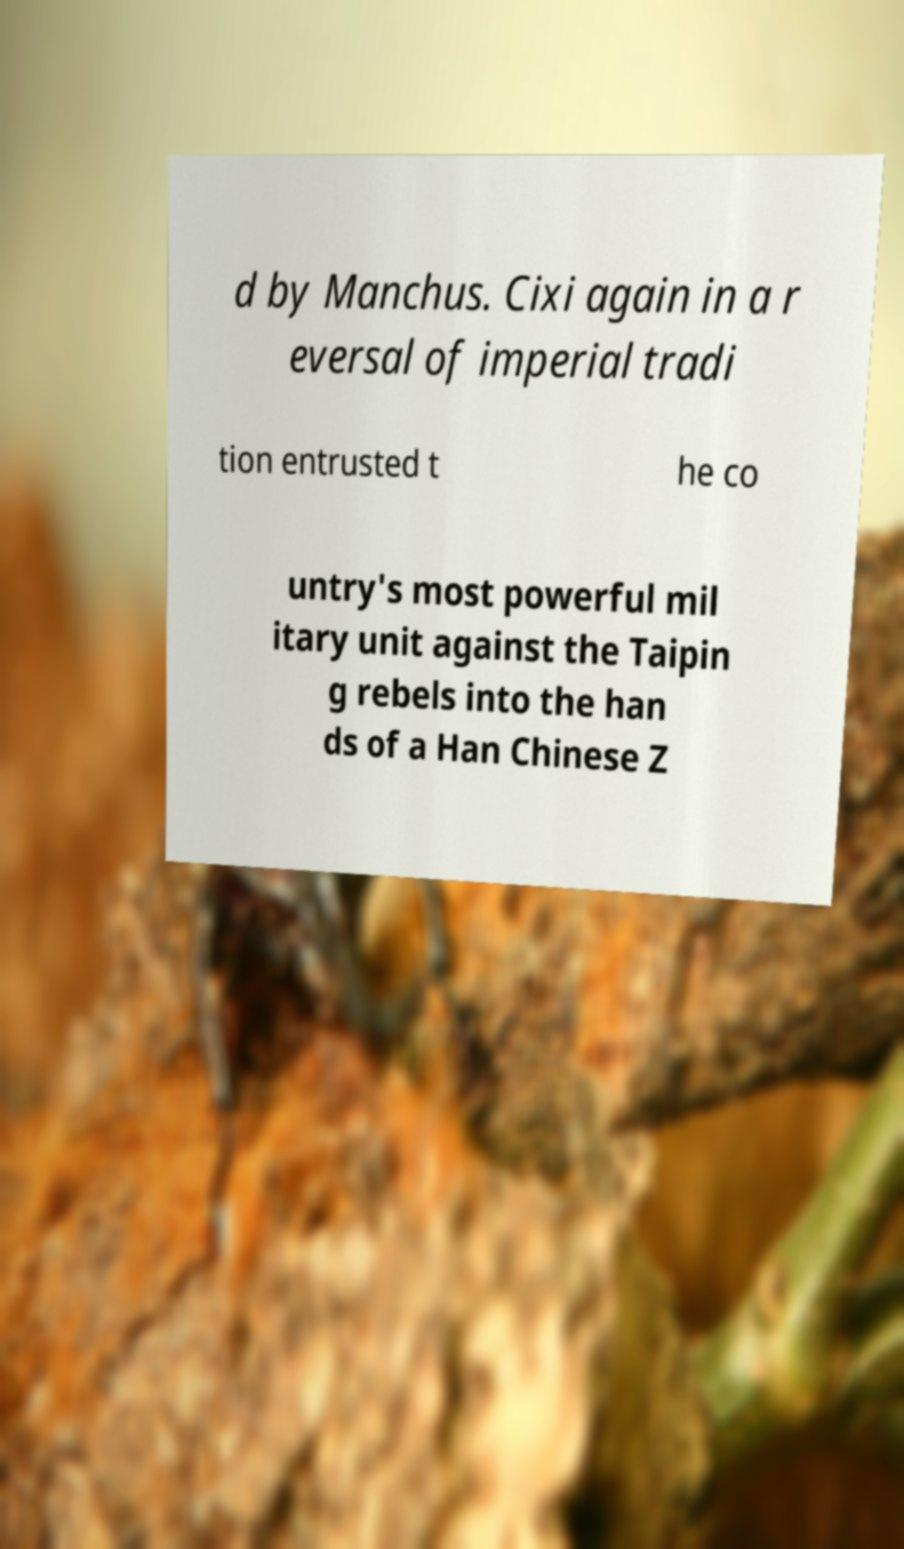Could you assist in decoding the text presented in this image and type it out clearly? d by Manchus. Cixi again in a r eversal of imperial tradi tion entrusted t he co untry's most powerful mil itary unit against the Taipin g rebels into the han ds of a Han Chinese Z 